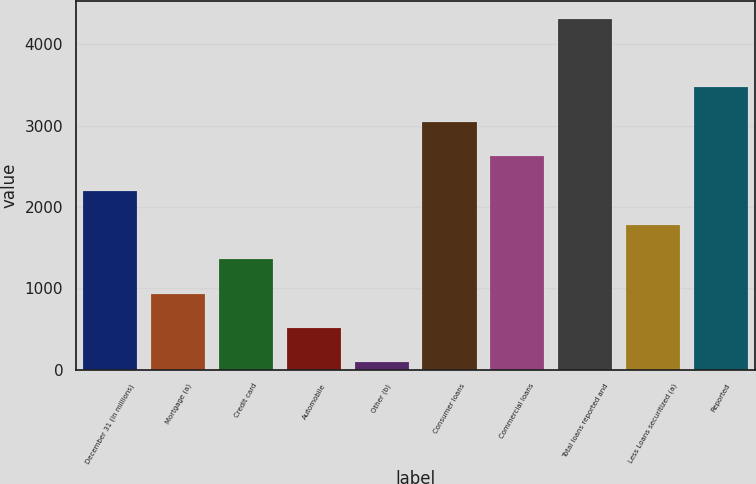<chart> <loc_0><loc_0><loc_500><loc_500><bar_chart><fcel>December 31 (in millions)<fcel>Mortgage (a)<fcel>Credit card<fcel>Automobile<fcel>Other (b)<fcel>Consumer loans<fcel>Commercial loans<fcel>Total loans reported and<fcel>Less Loans securitized (a)<fcel>Reported<nl><fcel>2203<fcel>933.4<fcel>1356.6<fcel>510.2<fcel>87<fcel>3049.4<fcel>2626.2<fcel>4319<fcel>1779.8<fcel>3472.6<nl></chart> 